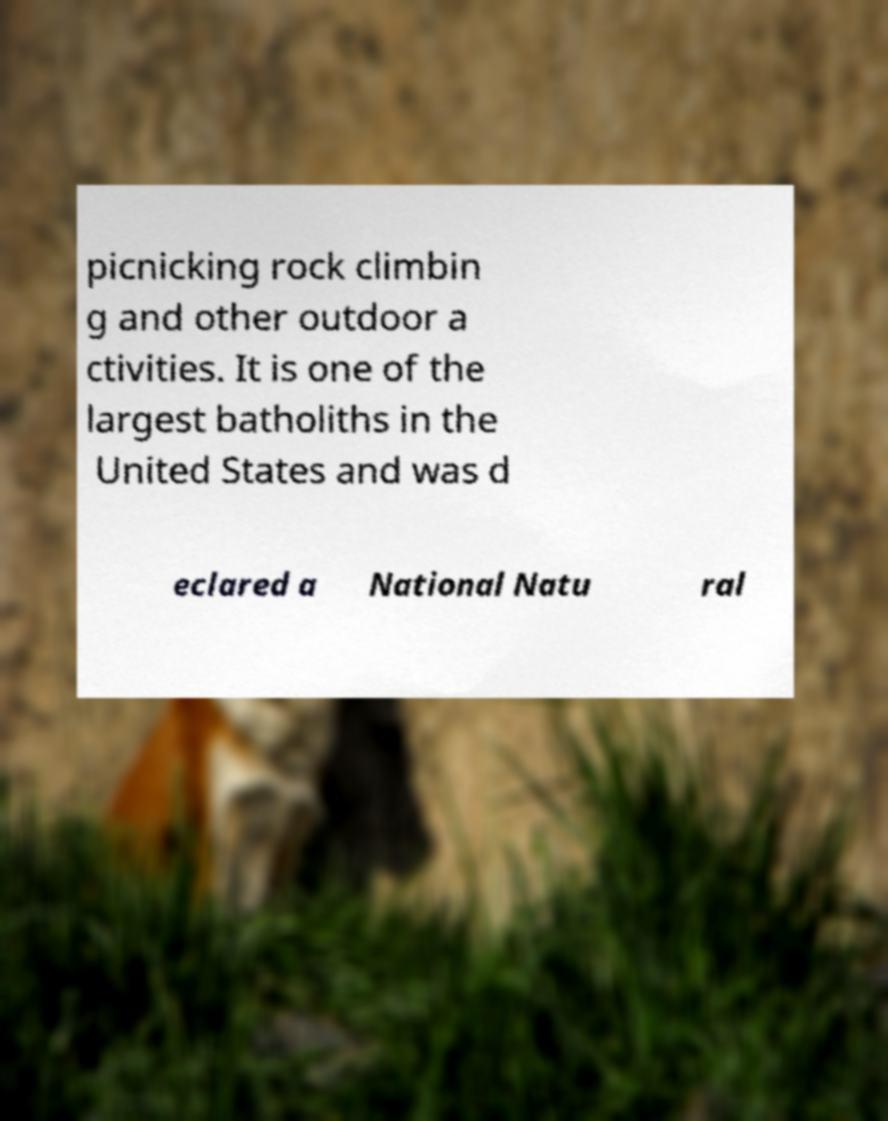Could you extract and type out the text from this image? picnicking rock climbin g and other outdoor a ctivities. It is one of the largest batholiths in the United States and was d eclared a National Natu ral 